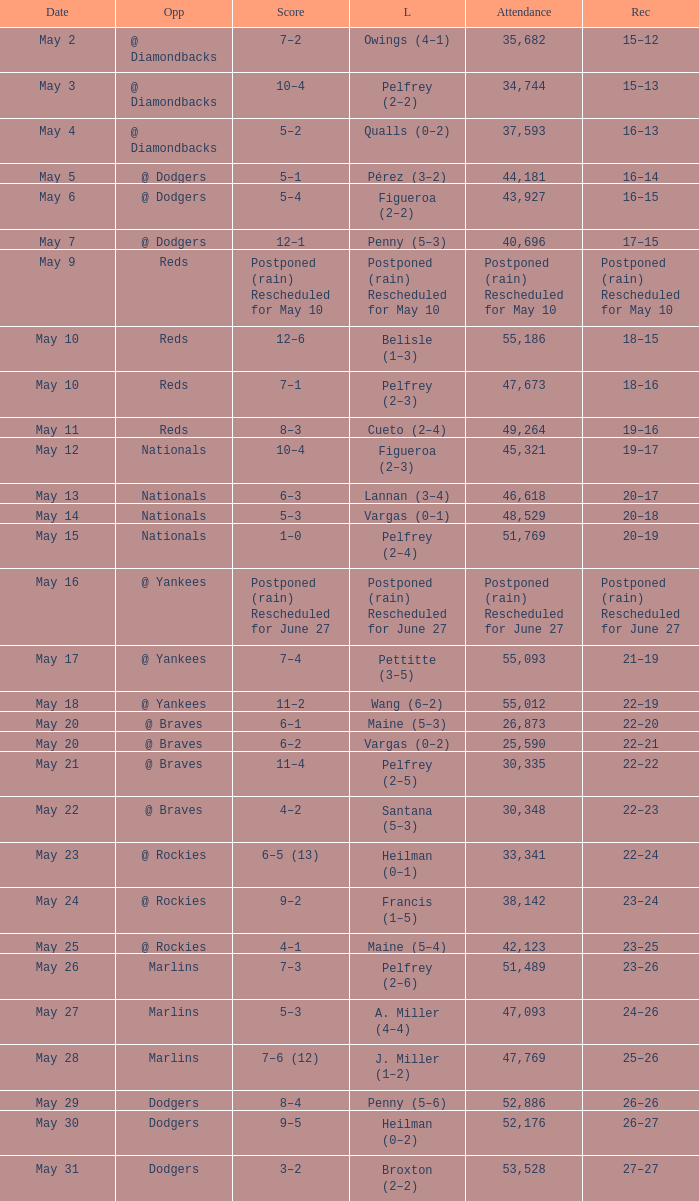Record of 19–16 occurred on what date? May 11. 